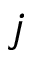<formula> <loc_0><loc_0><loc_500><loc_500>j</formula> 